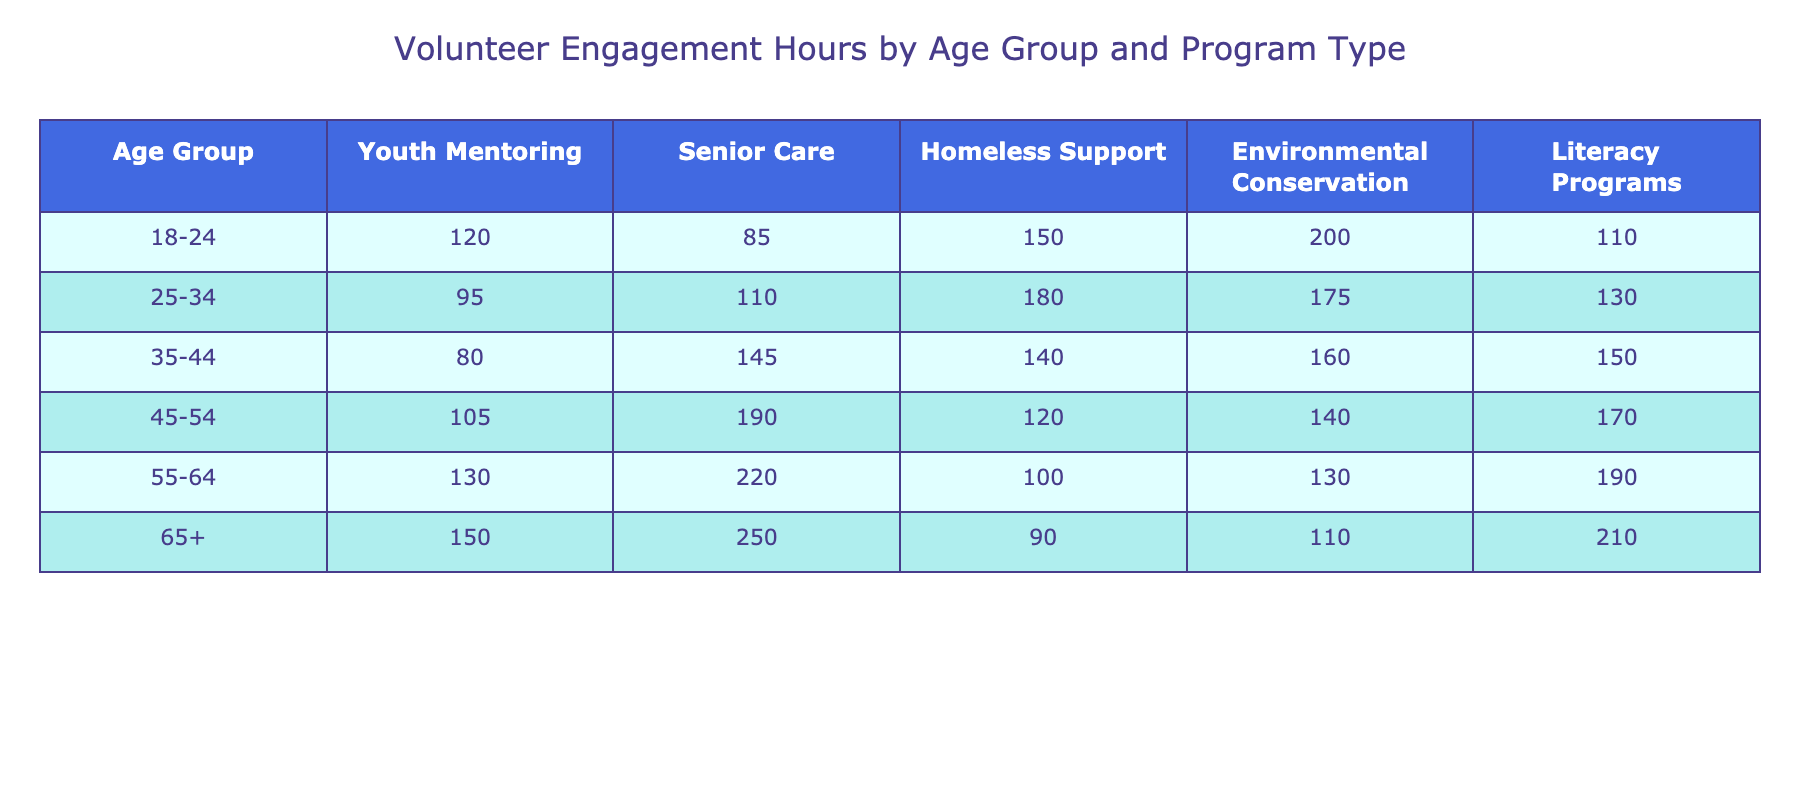What age group has the highest volunteer engagement hours in the Environmental Conservation program? By examining the table, the Environmental Conservation program has the highest engagement hours in the 18-24 age group with 200 hours.
Answer: 18-24 What is the total number of volunteer hours for the 65+ age group across all program types? To find the total, add the engagement hours: 150 (Youth Mentoring) + 250 (Senior Care) + 90 (Homeless Support) + 110 (Environmental Conservation) + 210 (Literacy Programs) = 810 hours.
Answer: 810 Which program type has the least volunteer engagement hours for the 45-54 age group? In the 45-54 age group, the program with the least hours is Homeless Support, with 120 hours, compared to the others listed: 105 (Youth Mentoring), 190 (Senior Care), 140 (Environmental Conservation), and 170 (Literacy Programs).
Answer: Homeless Support What is the average number of volunteer engagement hours for the age group 55-64 across all programs? To calculate the average, add the hours: 130 (Youth Mentoring) + 220 (Senior Care) + 100 (Homeless Support) + 130 (Environmental Conservation) + 190 (Literacy Programs) = 770. Then, divide by the number of programs (5): 770 / 5 = 154.
Answer: 154 Is it true that engagement hours for the 25-34 age group in Senior Care exceed those in Youth Mentoring? Yes, the hours for the 25-34 age group in Senior Care are 110, while in Youth Mentoring, they are 95. Thus, it is true that Senior Care exceeds Youth Mentoring for that age group.
Answer: Yes Which age group shows the greatest increase in engagement hours from Youth Mentoring to Environmental Conservation? By comparing the differences in engagement hours, 200 (Environmental Conservation) - 120 (Youth Mentoring) for the 18-24 age group gives an increase of 80. For other groups, the increases are: 80 (25-34), 80 (35-44), 60 (45-54), 60 (55-64), and 110 (65+). The 65+ age group shows the greatest increase of 110 hours.
Answer: 65+ How many more hours does the 55-64 age group spend on Literacy Programs than the 35-44 age group? The 55-64 age group spends 190 hours on Literacy Programs while the 35-44 age group spends 150 hours. Subtracting gives 190 - 150 = 40 hours more for the 55-64 group.
Answer: 40 What is the total engagement for the Senior Care program across all age groups? The total for Senior Care can be calculated by adding the hours: 85 (18-24) + 110 (25-34) + 145 (35-44) + 190 (45-54) + 220 (55-64) + 250 (65+) = 1,100 hours.
Answer: 1,100 Which age group has the highest total volunteer hours in the Homeless Support program? The 25-34 age group has 180 hours in the Homeless Support program, which is the highest when compared to other age groups: 150 (18-24), 140 (35-44), 120 (45-54), 100 (55-64), and 90 (65+).
Answer: 25-34 What is the difference in total volunteer hours between the 18-24 and 55-64 age groups across all programs? First, calculate the totals: 120 + 85 + 150 + 200 + 110 = 665 hours for 18-24 and 130 + 220 + 100 + 130 + 190 = 770 hours for 55-64. Then, subtract the two totals: 770 - 665 = 105 hours difference.
Answer: 105 